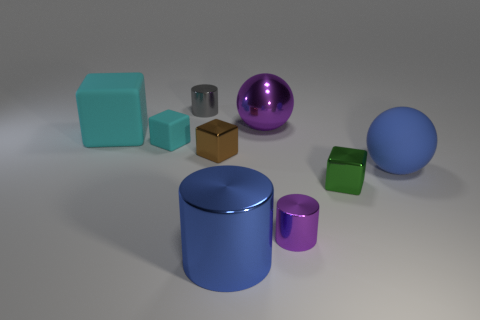Subtract all cyan blocks. How many were subtracted if there are1cyan blocks left? 1 Subtract 1 blocks. How many blocks are left? 3 Add 1 small green things. How many objects exist? 10 Subtract all balls. How many objects are left? 7 Add 9 small cyan cubes. How many small cyan cubes are left? 10 Add 8 cyan blocks. How many cyan blocks exist? 10 Subtract 0 green cylinders. How many objects are left? 9 Subtract all large rubber balls. Subtract all brown cubes. How many objects are left? 7 